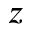Convert formula to latex. <formula><loc_0><loc_0><loc_500><loc_500>z</formula> 